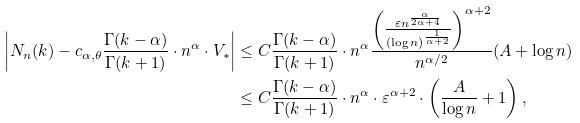<formula> <loc_0><loc_0><loc_500><loc_500>\left | N _ { n } ( k ) - c _ { \alpha , \theta } \frac { \Gamma ( k - \alpha ) } { \Gamma ( k + 1 ) } \cdot n ^ { \alpha } \cdot V _ { * } \right | & \leq C \frac { \Gamma ( k - \alpha ) } { \Gamma ( k + 1 ) } \cdot n ^ { \alpha } \frac { \left ( \frac { \varepsilon n ^ { \frac { \alpha } { 2 \alpha + 4 } } } { ( \log n ) ^ { \frac { 1 } { \alpha + 2 } } } \right ) ^ { \alpha + 2 } } { n ^ { \alpha / 2 } } ( A + \log n ) \\ & \leq C \frac { \Gamma ( k - \alpha ) } { \Gamma ( k + 1 ) } \cdot n ^ { \alpha } \cdot \varepsilon ^ { \alpha + 2 } \cdot \left ( \frac { A } { \log n } + 1 \right ) ,</formula> 